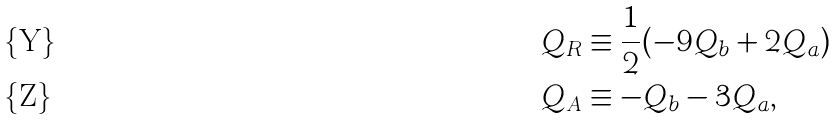<formula> <loc_0><loc_0><loc_500><loc_500>Q _ { R } & \equiv \frac { 1 } { 2 } ( - 9 Q _ { b } + 2 Q _ { a } ) \\ Q _ { A } & \equiv - Q _ { b } - 3 Q _ { a } ,</formula> 